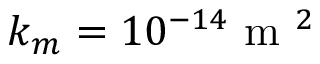Convert formula to latex. <formula><loc_0><loc_0><loc_500><loc_500>k _ { m } = 1 0 ^ { - 1 4 } m ^ { 2 }</formula> 